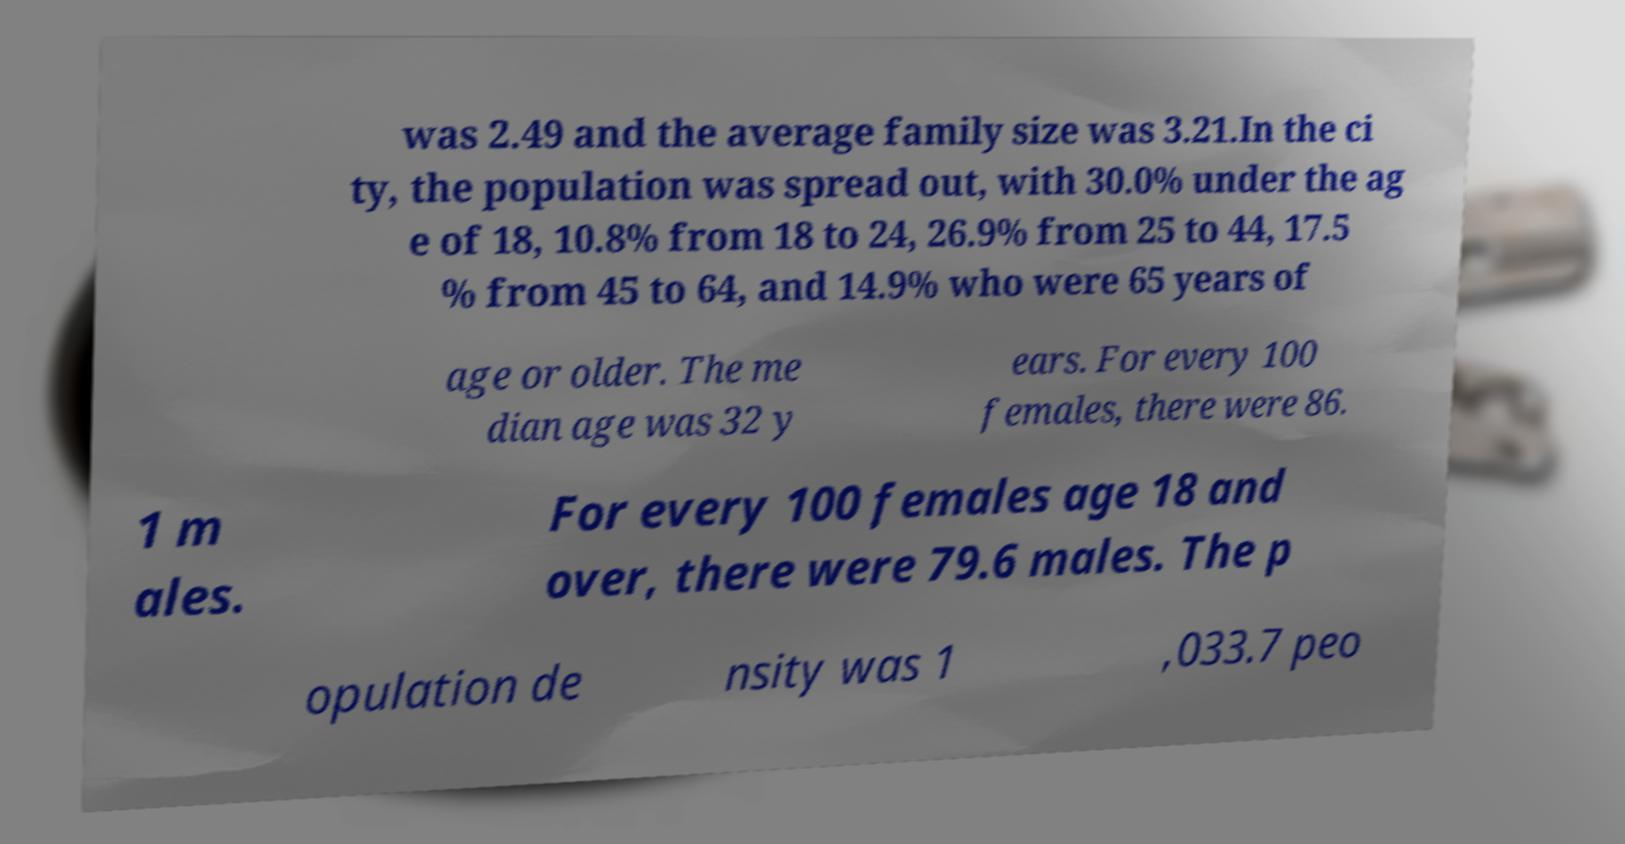Could you extract and type out the text from this image? was 2.49 and the average family size was 3.21.In the ci ty, the population was spread out, with 30.0% under the ag e of 18, 10.8% from 18 to 24, 26.9% from 25 to 44, 17.5 % from 45 to 64, and 14.9% who were 65 years of age or older. The me dian age was 32 y ears. For every 100 females, there were 86. 1 m ales. For every 100 females age 18 and over, there were 79.6 males. The p opulation de nsity was 1 ,033.7 peo 